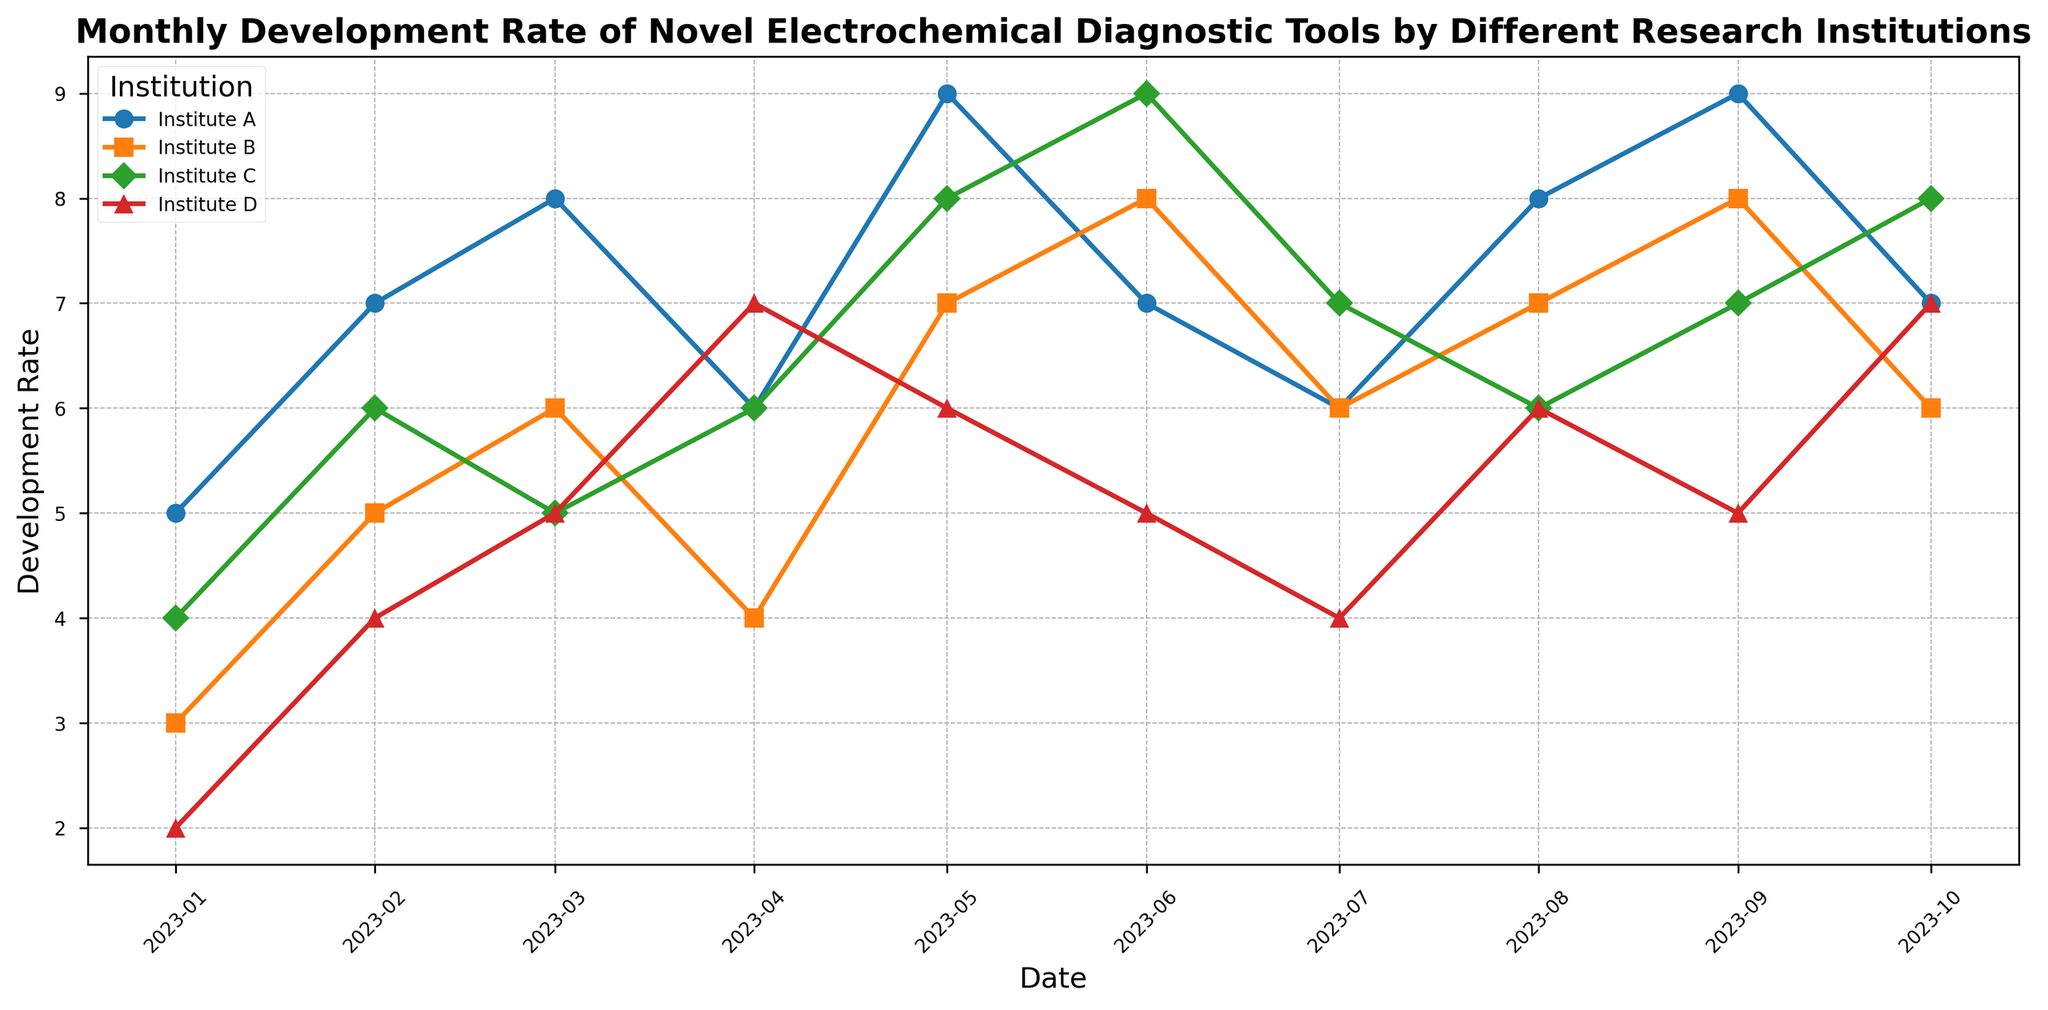What's the overall trend for Institute A's development rate from January 2023 to October 2023? Institute A's development rate shows a generally increasing trend with some fluctuations. Starting from January 2023 with a development rate of 5, it peaks at 9 in May and September, with slight dips in other months, ending at 7 in October.
Answer: Generally increasing with fluctuations Between which months does Institute B show the most significant increase in development rate? For Institute B, the most significant increase in development rate occurs between April 2023 (4) and May 2023 (7), where the rate jumps by 3 units.
Answer: April to May Which institution has the highest development rate in June 2023? Visually checking the June 2023 mark, Institute C has the highest development rate with a value of 9, compared to Institute A and Institute B both at 7, and Institute D at 5.
Answer: Institute C Which months does Institute D show a development rate higher than or equal to Institute B? By comparing the visual points: Institute D's rate is equal to or higher than Institute B in April (7 vs. 4), August (6 vs. 7), and October (7 vs. 6).
Answer: April, August, October What’s the average development rate of Institute C from January to October 2023? Compute the average: (4+6+5+6+8+9+7+6+7+8)/10 = 66/10 = 6.6.
Answer: 6.6 How does the development rate of Institute A in August compare to its rate in January? Institute A's development rate in August (8) is higher than in January (5). The rate increases by 3 units.
Answer: Higher by 3 In which month does Institute C reach its peak development rate, and what is the value? Institute C reaches its peak development rate in June 2023 with a value of 9, the highest markpoint for Institute C.
Answer: June 2023, 9 Which institution has the most consistent development rate trend from January to October? By examining the visual consistency of growth, Institute B displays the most steady and gradual changes, without sharp peaks or dips.
Answer: Institute B What's the difference in development rate between Institute A and Institute D in October? The development rate in October for Institute A is 7 and for Institute D is 7. The difference is 7 - 7 = 0.
Answer: 0 